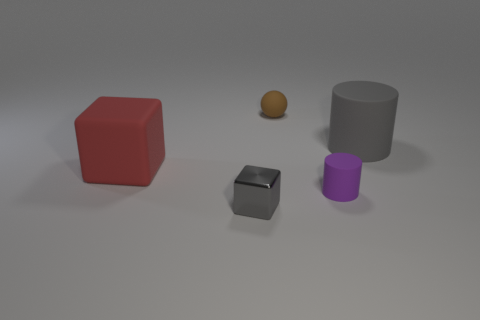Is there any other thing that has the same shape as the purple thing?
Ensure brevity in your answer.  Yes. Is the number of big red things greater than the number of yellow shiny cylinders?
Your response must be concise. Yes. How many things are behind the small gray metallic object and to the right of the big red block?
Provide a succinct answer. 3. There is a rubber object that is to the right of the small purple rubber object; how many matte cylinders are in front of it?
Your answer should be compact. 1. Is the size of the gray object behind the red rubber cube the same as the matte object that is to the left of the brown matte object?
Offer a terse response. Yes. How many yellow rubber balls are there?
Your response must be concise. 0. What number of brown things are made of the same material as the large red thing?
Your answer should be very brief. 1. Is the number of tiny brown rubber objects in front of the red object the same as the number of purple metallic balls?
Your answer should be very brief. Yes. There is another object that is the same color as the metal thing; what is its material?
Ensure brevity in your answer.  Rubber. There is a purple matte cylinder; is its size the same as the gray object that is behind the tiny purple matte object?
Give a very brief answer. No. 